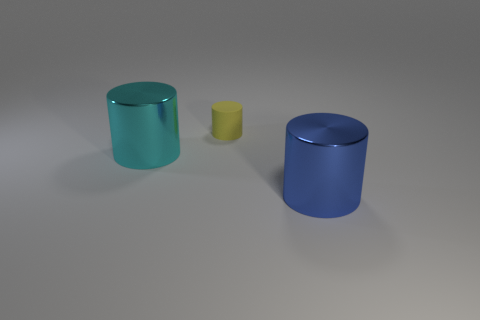What can you tell me about the largest object in the image? The largest object in the image is a cylinder with a reflective blue surface. It appears to be made of a metallic material, judging by the shiny finish and the way it reflects light. 